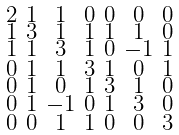<formula> <loc_0><loc_0><loc_500><loc_500>\begin{smallmatrix} 2 & 1 & 1 & 0 & 0 & 0 & 0 \\ 1 & 3 & 1 & 1 & 1 & 1 & 0 \\ 1 & 1 & 3 & 1 & 0 & - 1 & 1 \\ 0 & 1 & 1 & 3 & 1 & 0 & 1 \\ 0 & 1 & 0 & 1 & 3 & 1 & 0 \\ 0 & 1 & - 1 & 0 & 1 & 3 & 0 \\ 0 & 0 & 1 & 1 & 0 & 0 & 3 \end{smallmatrix}</formula> 